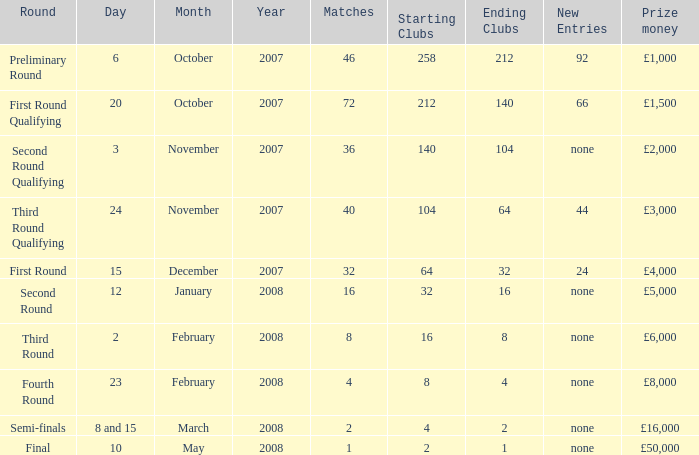What are the clubs with 46 matches? 258 → 212. 